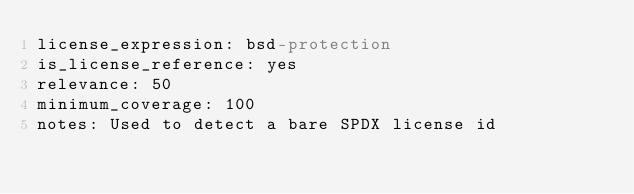<code> <loc_0><loc_0><loc_500><loc_500><_YAML_>license_expression: bsd-protection
is_license_reference: yes
relevance: 50
minimum_coverage: 100
notes: Used to detect a bare SPDX license id
</code> 